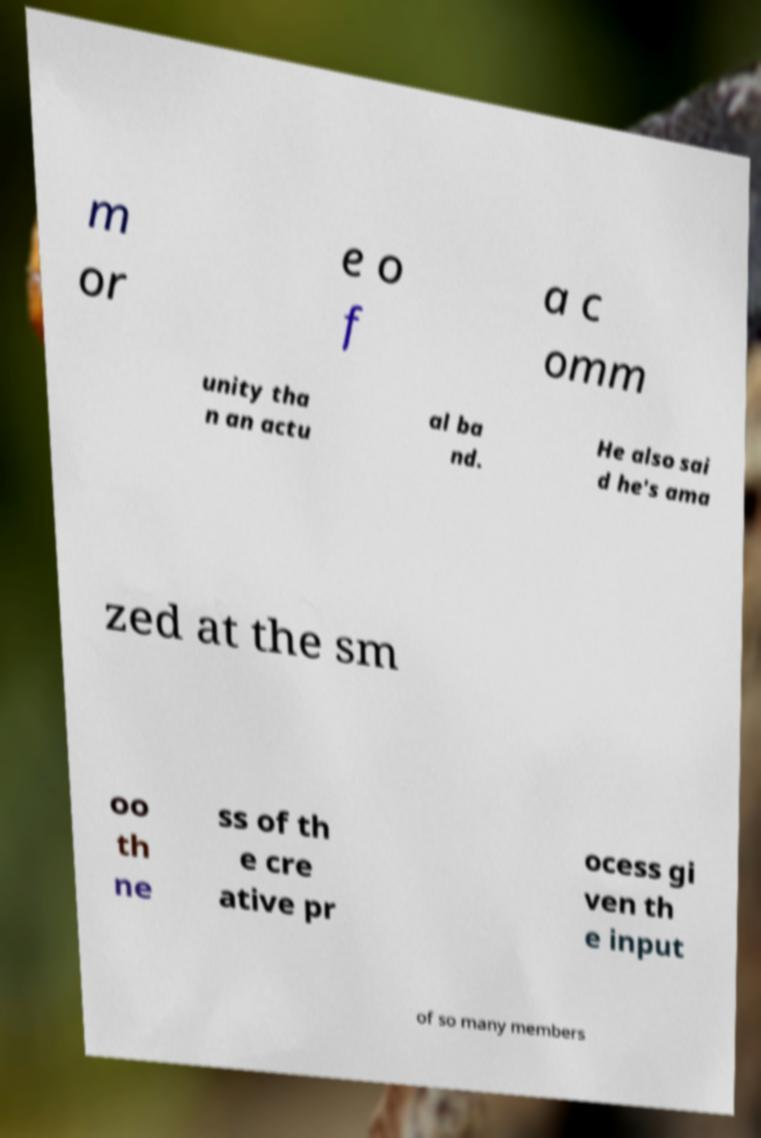Could you extract and type out the text from this image? m or e o f a c omm unity tha n an actu al ba nd. He also sai d he's ama zed at the sm oo th ne ss of th e cre ative pr ocess gi ven th e input of so many members 